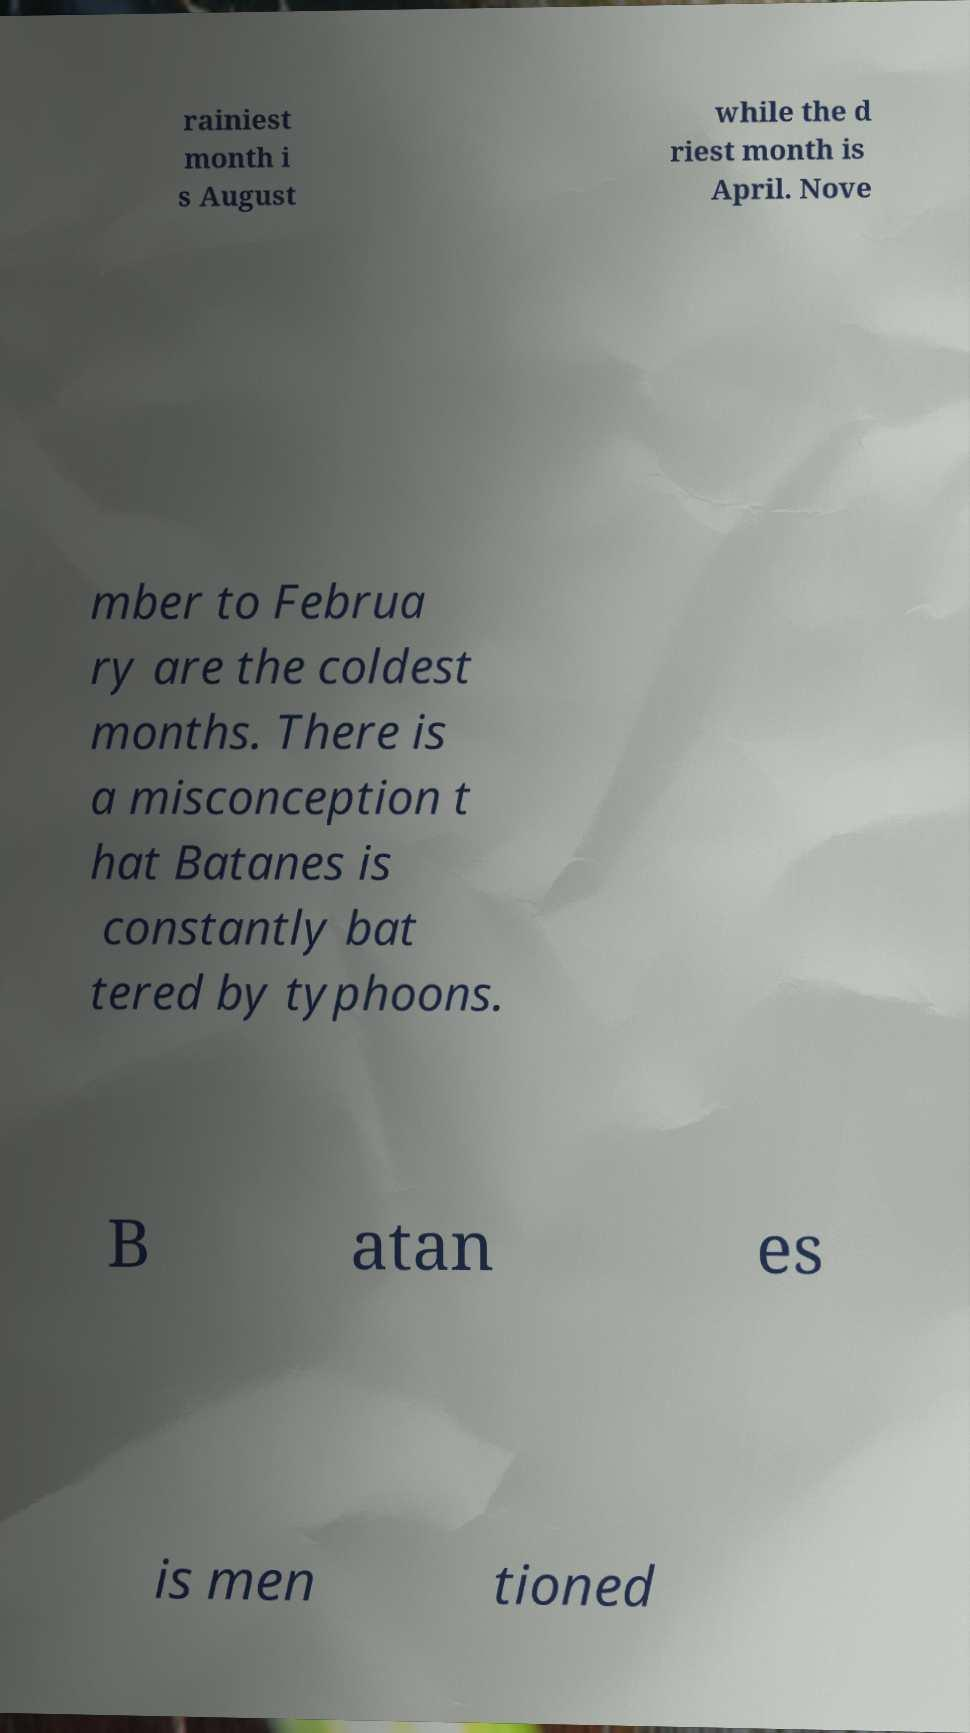There's text embedded in this image that I need extracted. Can you transcribe it verbatim? rainiest month i s August while the d riest month is April. Nove mber to Februa ry are the coldest months. There is a misconception t hat Batanes is constantly bat tered by typhoons. B atan es is men tioned 